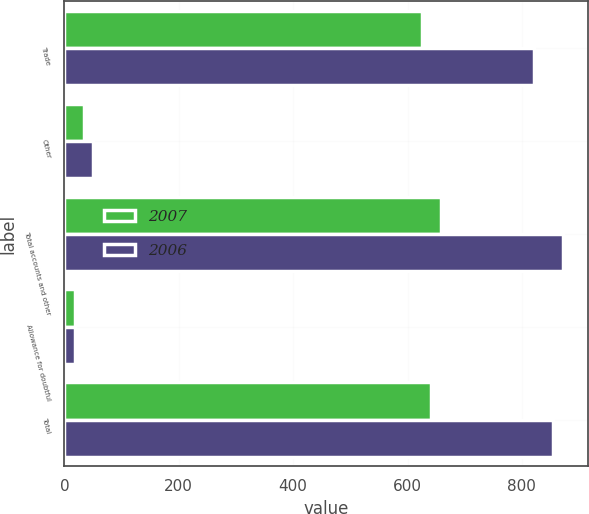<chart> <loc_0><loc_0><loc_500><loc_500><stacked_bar_chart><ecel><fcel>Trade<fcel>Other<fcel>Total accounts and other<fcel>Allowance for doubtful<fcel>Total<nl><fcel>2007<fcel>624.7<fcel>33.7<fcel>658.4<fcel>18.2<fcel>640.2<nl><fcel>2006<fcel>821.7<fcel>50.2<fcel>871.9<fcel>18.1<fcel>853.8<nl></chart> 